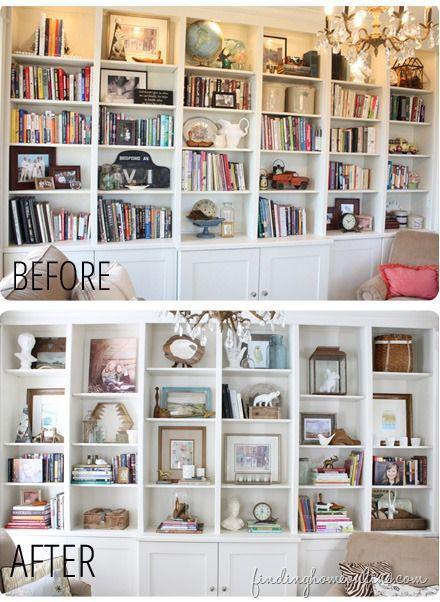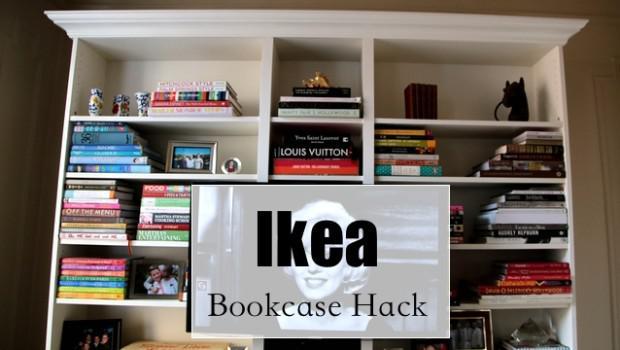The first image is the image on the left, the second image is the image on the right. Given the left and right images, does the statement "In one image, living room couches and coffee table are arranged in front of a large shelving unit." hold true? Answer yes or no. No. 